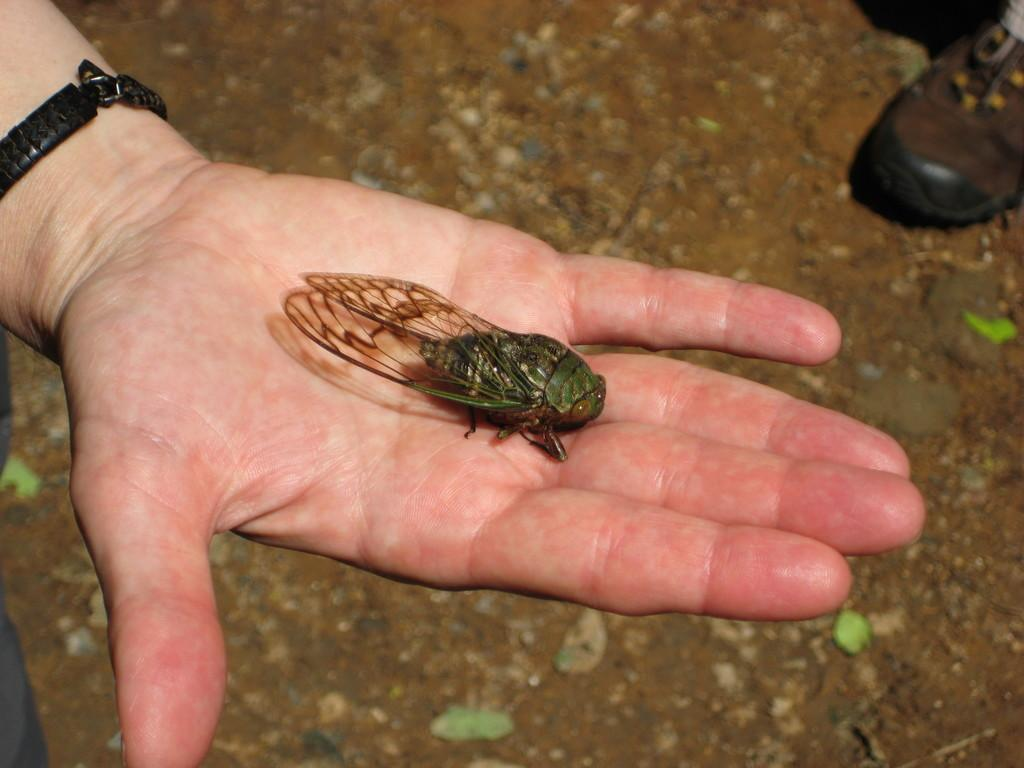What is being held in the hand in the image? There is an insect in the hand in the image. Where is the shoe located in the image? The shoe is in the top right corner of the image. What type of pie is being served on the thumb in the image? There is no pie or thumb present in the image. 